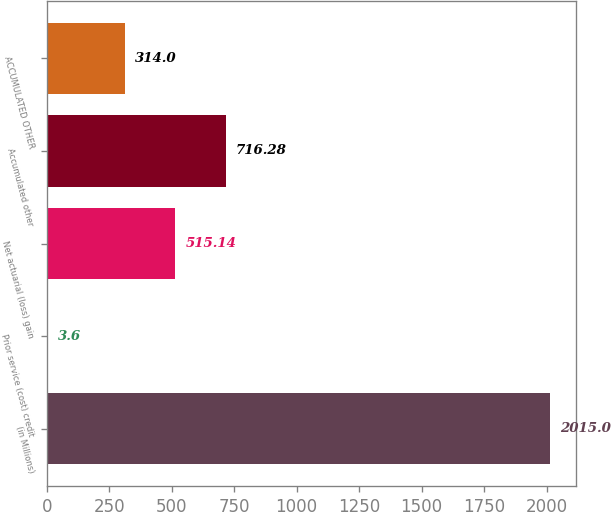<chart> <loc_0><loc_0><loc_500><loc_500><bar_chart><fcel>(in Millions)<fcel>Prior service (cost) credit<fcel>Net actuarial (loss) gain<fcel>Accumulated other<fcel>ACCUMULATED OTHER<nl><fcel>2015<fcel>3.6<fcel>515.14<fcel>716.28<fcel>314<nl></chart> 